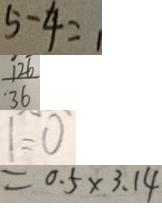Convert formula to latex. <formula><loc_0><loc_0><loc_500><loc_500>5 - 4 = 1 
 \frac { 1 2 6 } { 3 6 } 
 1 = 0 
 = 0 . 5 \times 3 . 1 4</formula> 